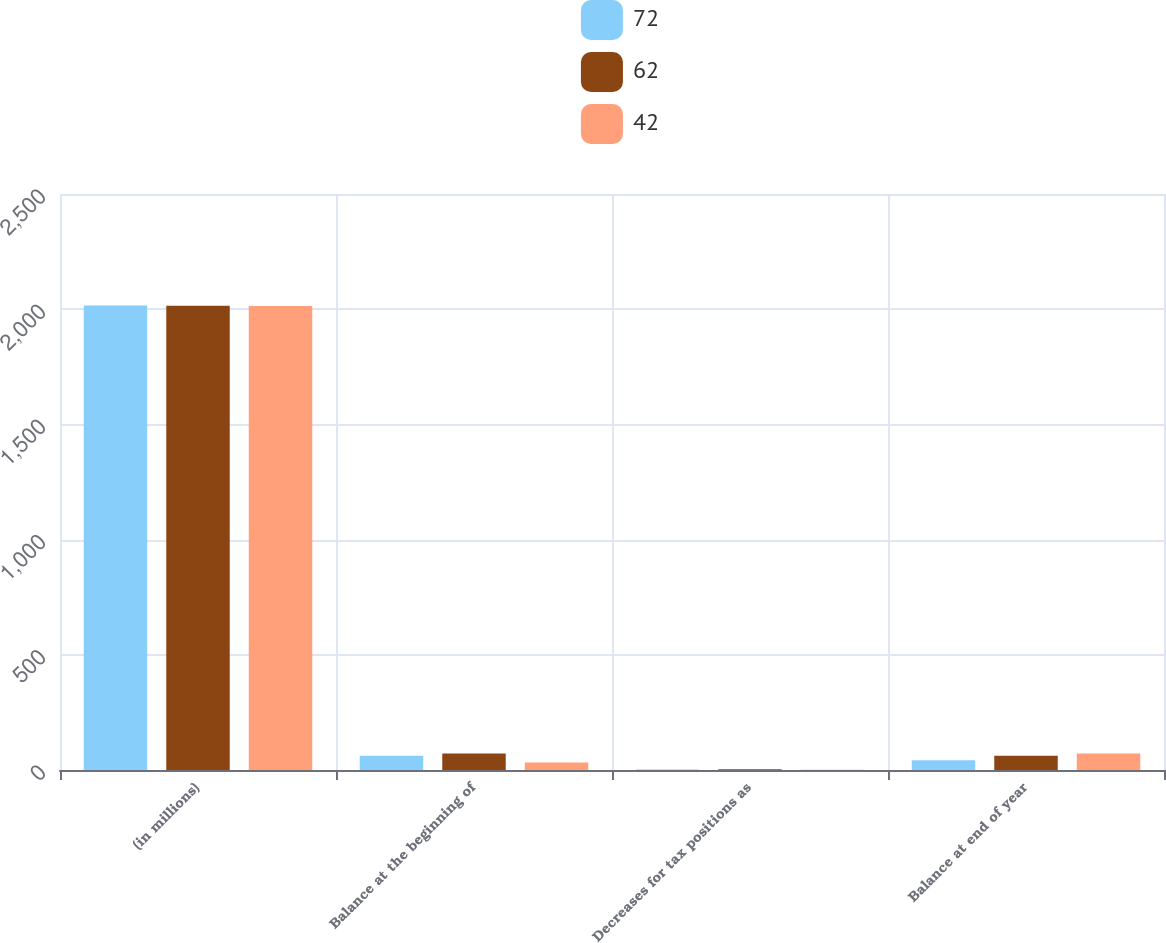Convert chart to OTSL. <chart><loc_0><loc_0><loc_500><loc_500><stacked_bar_chart><ecel><fcel>(in millions)<fcel>Balance at the beginning of<fcel>Decreases for tax positions as<fcel>Balance at end of year<nl><fcel>72<fcel>2016<fcel>62<fcel>2<fcel>42<nl><fcel>62<fcel>2015<fcel>72<fcel>3<fcel>62<nl><fcel>42<fcel>2014<fcel>33<fcel>1<fcel>72<nl></chart> 